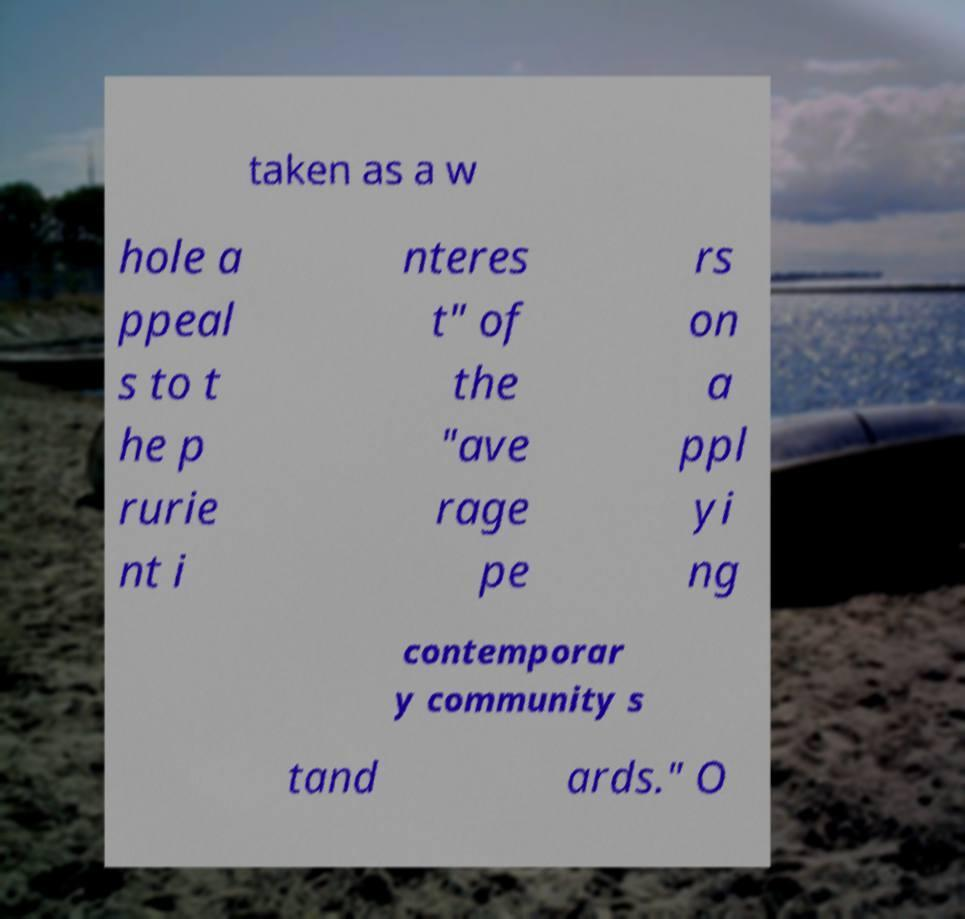I need the written content from this picture converted into text. Can you do that? taken as a w hole a ppeal s to t he p rurie nt i nteres t" of the "ave rage pe rs on a ppl yi ng contemporar y community s tand ards." O 